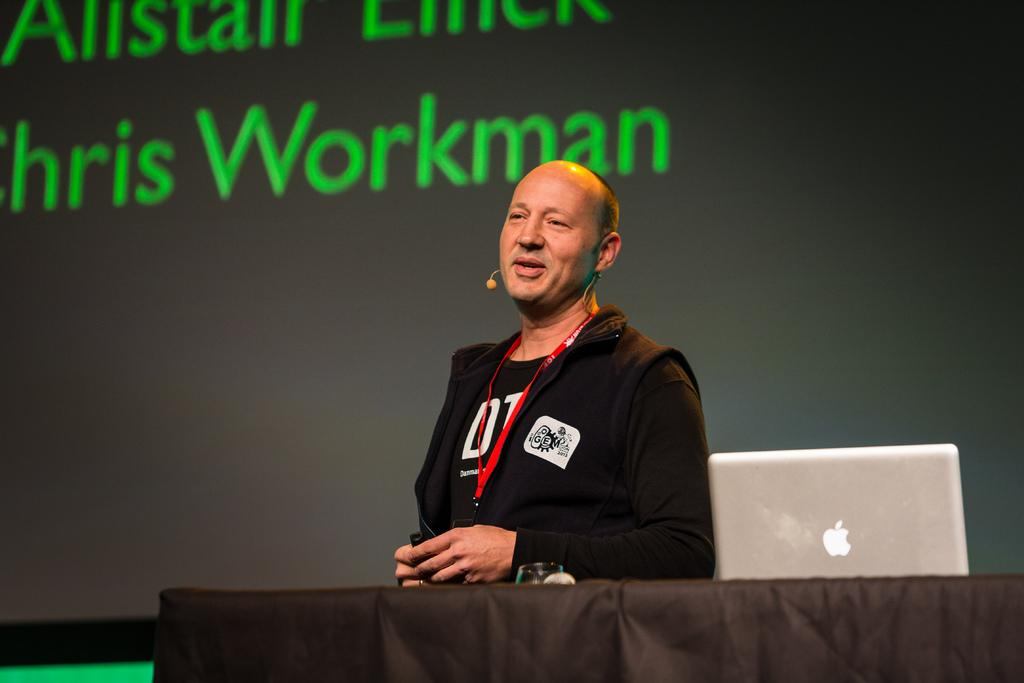Provide a one-sentence caption for the provided image. Workman is displayed on the screen behind the man speaking. 